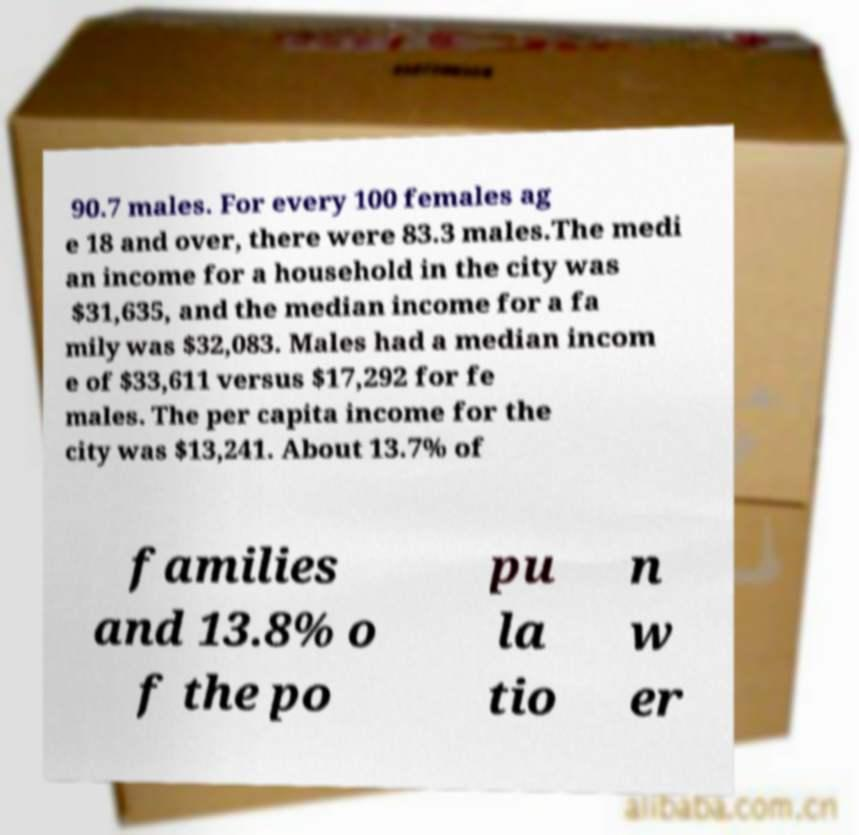What messages or text are displayed in this image? I need them in a readable, typed format. 90.7 males. For every 100 females ag e 18 and over, there were 83.3 males.The medi an income for a household in the city was $31,635, and the median income for a fa mily was $32,083. Males had a median incom e of $33,611 versus $17,292 for fe males. The per capita income for the city was $13,241. About 13.7% of families and 13.8% o f the po pu la tio n w er 